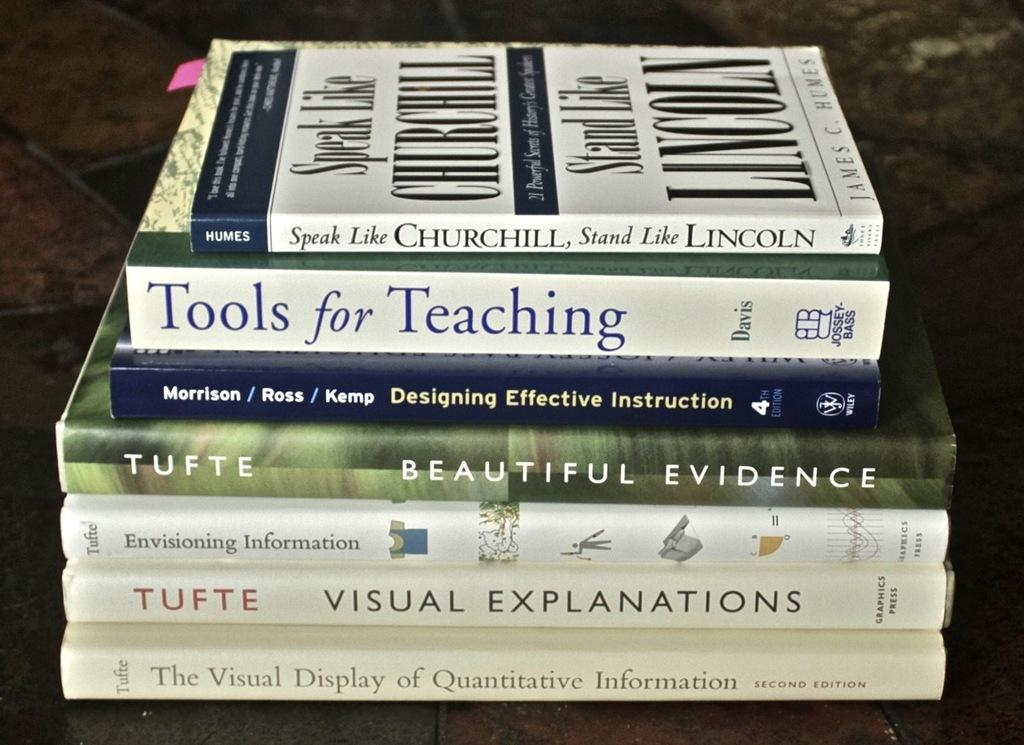<image>
Summarize the visual content of the image. Six books, horizontally stacked, one of whioch is Tools for Teaching and another called Beautiful Evidence. 